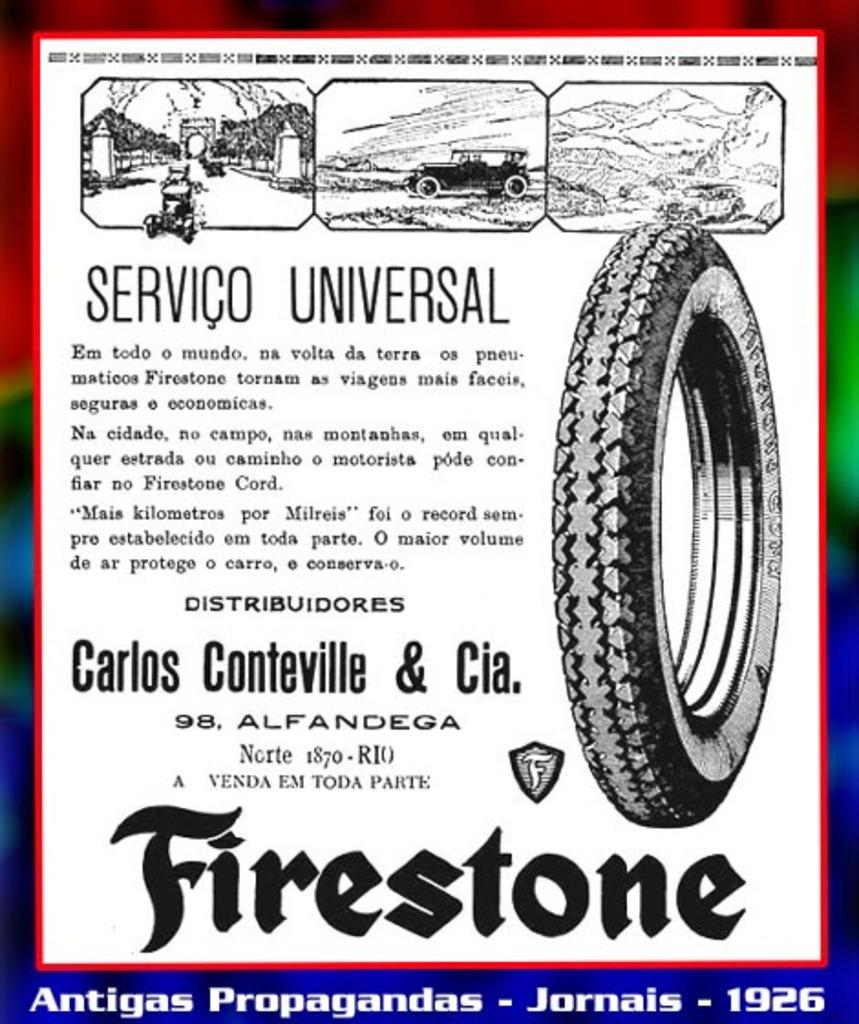What is the main subject of the poster in the image? There is a poster in the image, and it contains text and various images. Can you describe the content of the poster? The poster has images of vehicles, an image of a tire, and images of hills. There are also other unspecified images on the poster. What type of cushion is being used as a news anchor in the image? There is no cushion or news anchor present in the image; it only features a poster with various images and text. 